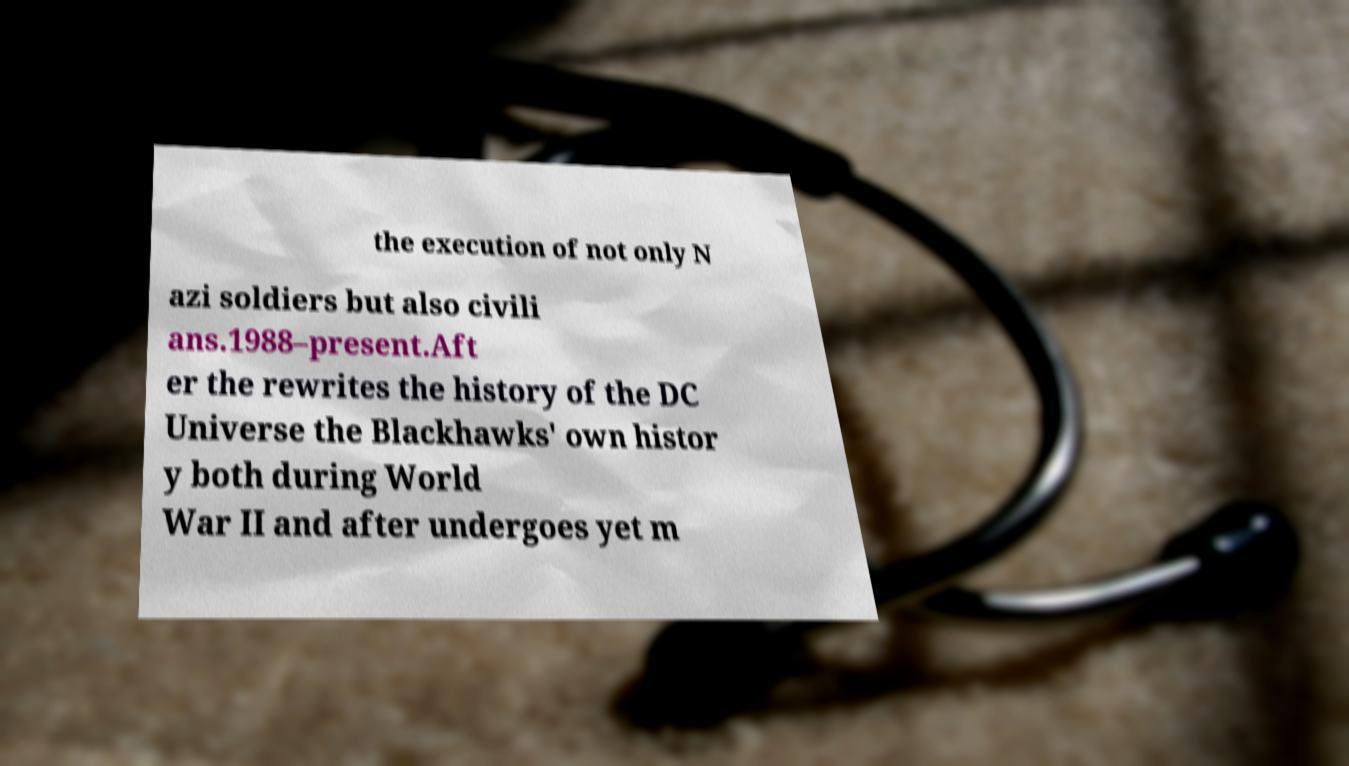For documentation purposes, I need the text within this image transcribed. Could you provide that? the execution of not only N azi soldiers but also civili ans.1988–present.Aft er the rewrites the history of the DC Universe the Blackhawks' own histor y both during World War II and after undergoes yet m 